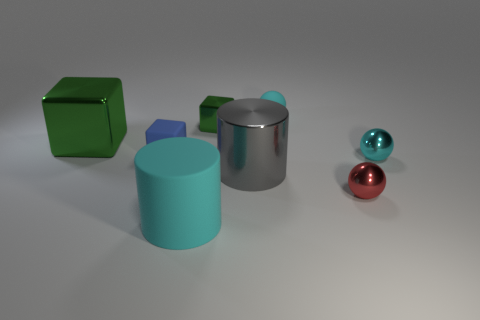Are there any other things that have the same size as the red shiny object?
Your response must be concise. Yes. There is a cyan matte thing right of the green thing that is on the right side of the large metallic block; what size is it?
Your response must be concise. Small. What is the color of the tiny shiny cube?
Offer a very short reply. Green. There is a green metal block right of the blue thing; what number of metal cubes are to the left of it?
Give a very brief answer. 1. There is a cyan sphere that is right of the cyan rubber sphere; are there any big things in front of it?
Keep it short and to the point. Yes. Are there any big gray objects in front of the blue block?
Ensure brevity in your answer.  Yes. There is a tiny rubber object left of the tiny green thing; is its shape the same as the red thing?
Your answer should be compact. No. What number of cyan metal objects have the same shape as the small red shiny thing?
Provide a succinct answer. 1. Are there any large cylinders made of the same material as the small blue block?
Offer a very short reply. Yes. There is a small cyan sphere that is to the right of the tiny rubber thing that is behind the tiny blue matte cube; what is it made of?
Your answer should be very brief. Metal. 